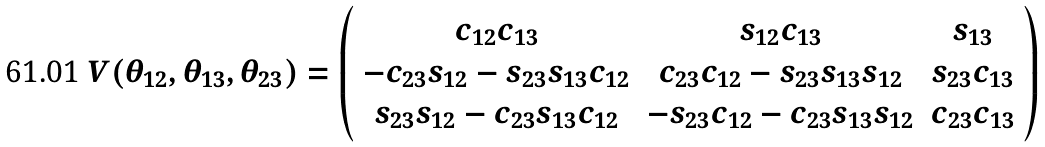Convert formula to latex. <formula><loc_0><loc_0><loc_500><loc_500>V ( \theta _ { 1 2 } , \theta _ { 1 3 } , \theta _ { 2 3 } ) = \left ( \begin{array} { c c c } c _ { 1 2 } c _ { 1 3 } & s _ { 1 2 } c _ { 1 3 } & s _ { 1 3 } \\ - c _ { 2 3 } s _ { 1 2 } - s _ { 2 3 } s _ { 1 3 } c _ { 1 2 } & c _ { 2 3 } c _ { 1 2 } - s _ { 2 3 } s _ { 1 3 } s _ { 1 2 } & s _ { 2 3 } c _ { 1 3 } \\ s _ { 2 3 } s _ { 1 2 } - c _ { 2 3 } s _ { 1 3 } c _ { 1 2 } & - s _ { 2 3 } c _ { 1 2 } - c _ { 2 3 } s _ { 1 3 } s _ { 1 2 } & c _ { 2 3 } c _ { 1 3 } \end{array} \right )</formula> 